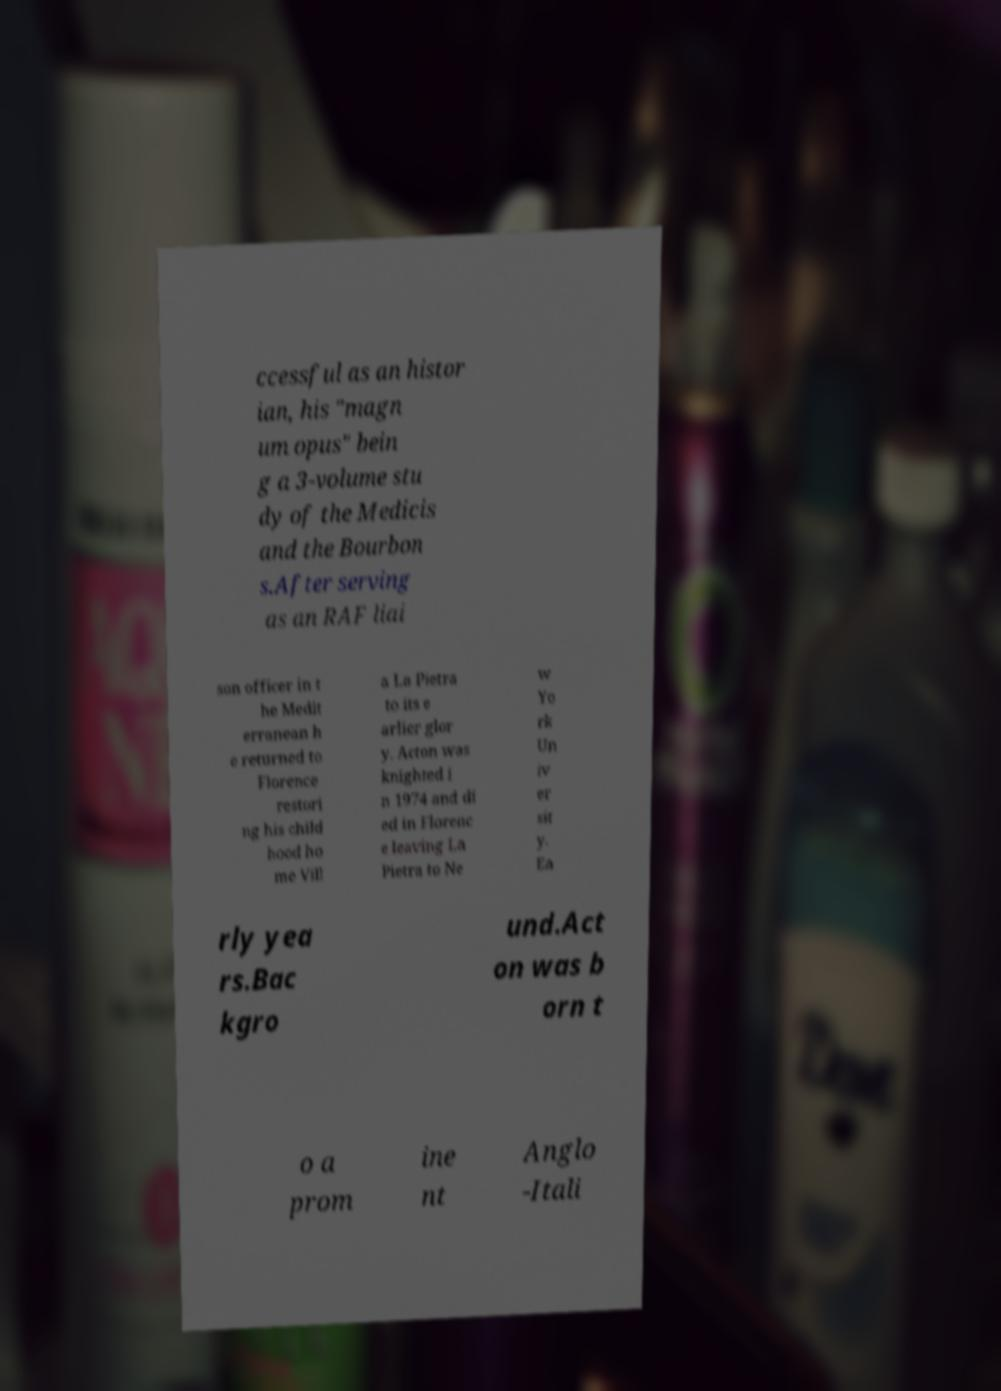Please identify and transcribe the text found in this image. ccessful as an histor ian, his "magn um opus" bein g a 3-volume stu dy of the Medicis and the Bourbon s.After serving as an RAF liai son officer in t he Medit erranean h e returned to Florence restori ng his child hood ho me Vill a La Pietra to its e arlier glor y. Acton was knighted i n 1974 and di ed in Florenc e leaving La Pietra to Ne w Yo rk Un iv er sit y. Ea rly yea rs.Bac kgro und.Act on was b orn t o a prom ine nt Anglo -Itali 